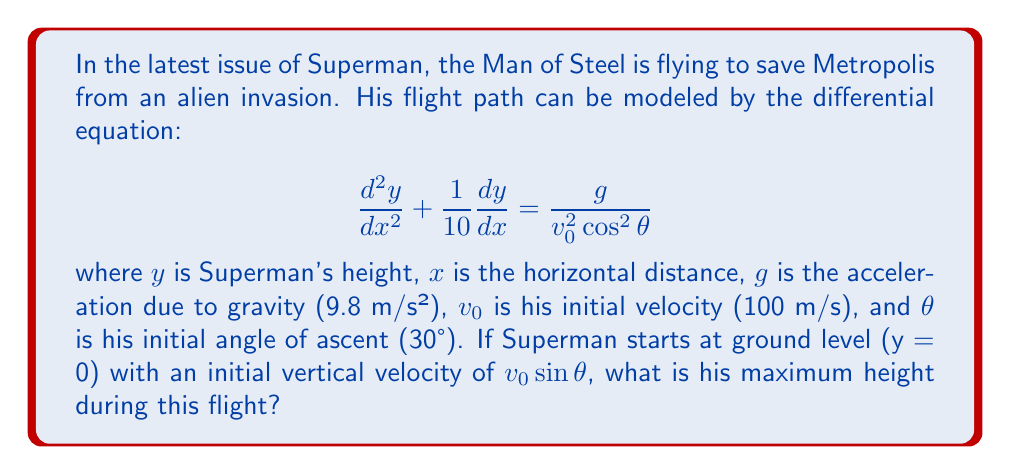Provide a solution to this math problem. Let's approach this step-by-step:

1) First, we need to solve the differential equation. This is a second-order linear differential equation with constant coefficients. The general solution has the form:

   $$y = Ax + B + C\exp(-\frac{x}{10})$$

2) To find A, we can substitute this general solution into the original equation:

   $$\frac{d^2y}{dx^2} + \frac{1}{10}\frac{dy}{dx} = 0 + \frac{1}{10}A - \frac{1}{100}C\exp(-\frac{x}{10}) + \frac{1}{100}C\exp(-\frac{x}{10}) = \frac{1}{10}A = \frac{g}{v_0^2\cos^2\theta}$$

3) Solving for A:

   $$A = \frac{10g}{v_0^2\cos^2\theta} = \frac{10 \cdot 9.8}{100^2 \cdot \cos^2(30°)} \approx 0.1131$$

4) Now we can use the initial conditions to find B and C:

   At x = 0, y = 0: $0 = B + C$
   At x = 0, $\frac{dy}{dx} = v_0\sin\theta$: $v_0\sin\theta = A + \frac{C}{10}$

5) Solving these equations:

   $C = -B$
   $v_0\sin\theta = A - \frac{B}{10}$
   $B = 10(v_0\sin\theta - A) \approx 10(100\sin(30°) - 0.1131) \approx 499.869$
   $C = -B \approx -499.869$

6) Now we have the complete equation of Superman's trajectory:

   $$y = 0.1131x + 499.869 - 499.869\exp(-\frac{x}{10})$$

7) To find the maximum height, we need to find where $\frac{dy}{dx} = 0$:

   $$\frac{dy}{dx} = 0.1131 + 49.9869\exp(-\frac{x}{10}) = 0$$

8) Solving this equation:

   $$\exp(-\frac{x}{10}) = 0.002264$$
   $$x = -10\ln(0.002264) \approx 60.9$$

9) Substituting this x back into the equation for y gives us the maximum height:

   $$y_{max} = 0.1131(60.9) + 499.869 - 499.869\exp(-\frac{60.9}{10}) \approx 506.8$$

Therefore, Superman's maximum height during this flight is approximately 506.8 meters.
Answer: Superman's maximum height during this flight is approximately 506.8 meters. 